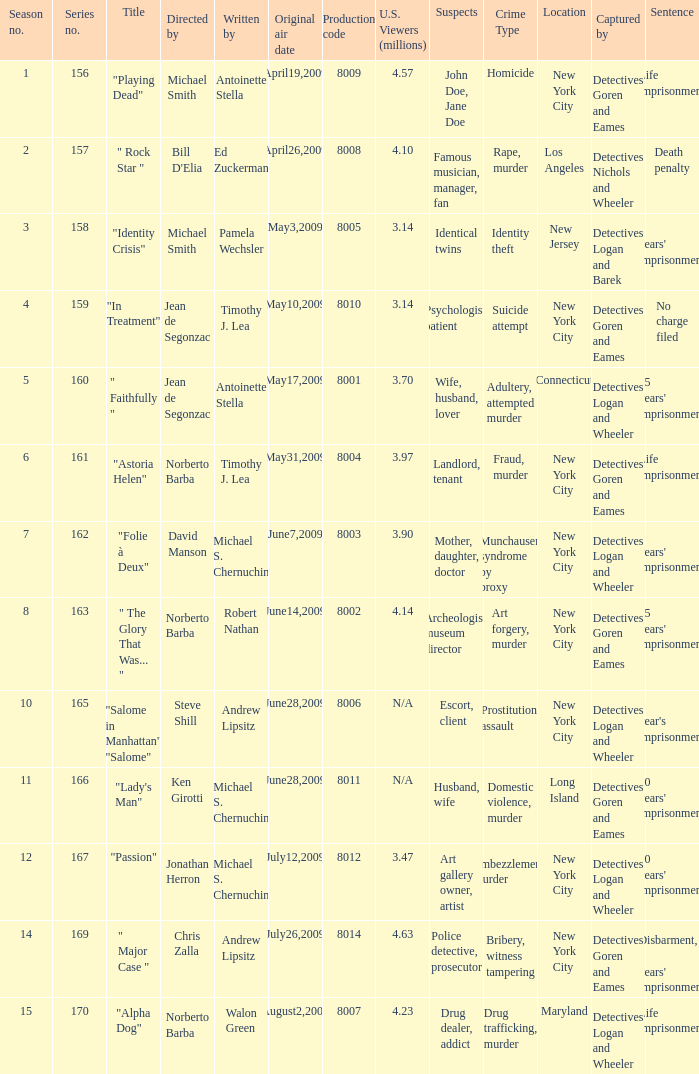Which is the  maximun serie episode number when the millions of north american spectators is 3.14? 159.0. 